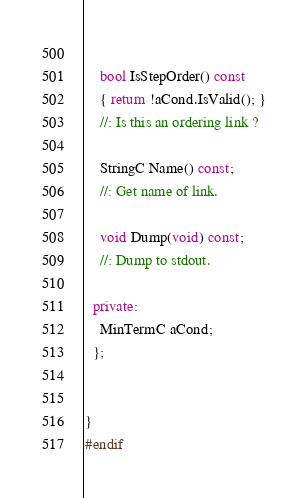<code> <loc_0><loc_0><loc_500><loc_500><_C++_>  
    bool IsStepOrder() const
    { return !aCond.IsValid(); }
    //: Is this an ordering link ?
    
    StringC Name() const;
    //: Get name of link.
    
    void Dump(void) const;
    //: Dump to stdout.
  
  private:
    MinTermC aCond;
  };
  
 
}
#endif
</code> 